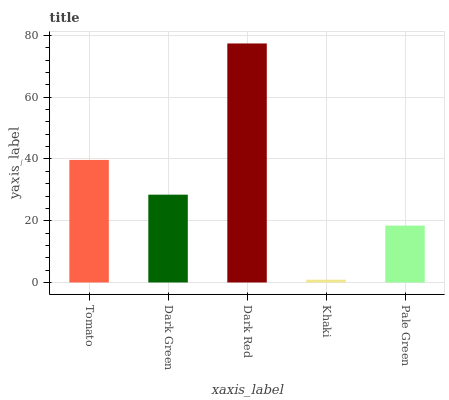Is Khaki the minimum?
Answer yes or no. Yes. Is Dark Red the maximum?
Answer yes or no. Yes. Is Dark Green the minimum?
Answer yes or no. No. Is Dark Green the maximum?
Answer yes or no. No. Is Tomato greater than Dark Green?
Answer yes or no. Yes. Is Dark Green less than Tomato?
Answer yes or no. Yes. Is Dark Green greater than Tomato?
Answer yes or no. No. Is Tomato less than Dark Green?
Answer yes or no. No. Is Dark Green the high median?
Answer yes or no. Yes. Is Dark Green the low median?
Answer yes or no. Yes. Is Khaki the high median?
Answer yes or no. No. Is Dark Red the low median?
Answer yes or no. No. 